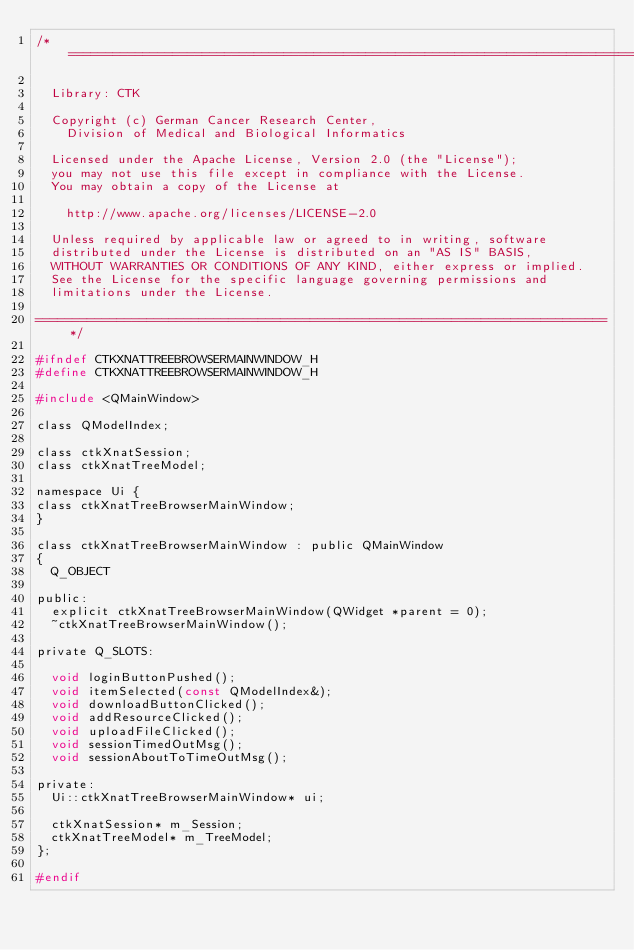Convert code to text. <code><loc_0><loc_0><loc_500><loc_500><_C_>/*=============================================================================

  Library: CTK

  Copyright (c) German Cancer Research Center,
    Division of Medical and Biological Informatics

  Licensed under the Apache License, Version 2.0 (the "License");
  you may not use this file except in compliance with the License.
  You may obtain a copy of the License at

    http://www.apache.org/licenses/LICENSE-2.0

  Unless required by applicable law or agreed to in writing, software
  distributed under the License is distributed on an "AS IS" BASIS,
  WITHOUT WARRANTIES OR CONDITIONS OF ANY KIND, either express or implied.
  See the License for the specific language governing permissions and
  limitations under the License.

=============================================================================*/

#ifndef CTKXNATTREEBROWSERMAINWINDOW_H
#define CTKXNATTREEBROWSERMAINWINDOW_H

#include <QMainWindow>

class QModelIndex;

class ctkXnatSession;
class ctkXnatTreeModel;

namespace Ui {
class ctkXnatTreeBrowserMainWindow;
}

class ctkXnatTreeBrowserMainWindow : public QMainWindow
{
  Q_OBJECT

public:
  explicit ctkXnatTreeBrowserMainWindow(QWidget *parent = 0);
  ~ctkXnatTreeBrowserMainWindow();

private Q_SLOTS:

  void loginButtonPushed();
  void itemSelected(const QModelIndex&);
  void downloadButtonClicked();
  void addResourceClicked();
  void uploadFileClicked();
  void sessionTimedOutMsg();
  void sessionAboutToTimeOutMsg();

private:
  Ui::ctkXnatTreeBrowserMainWindow* ui;

  ctkXnatSession* m_Session;
  ctkXnatTreeModel* m_TreeModel;
};

#endif
</code> 